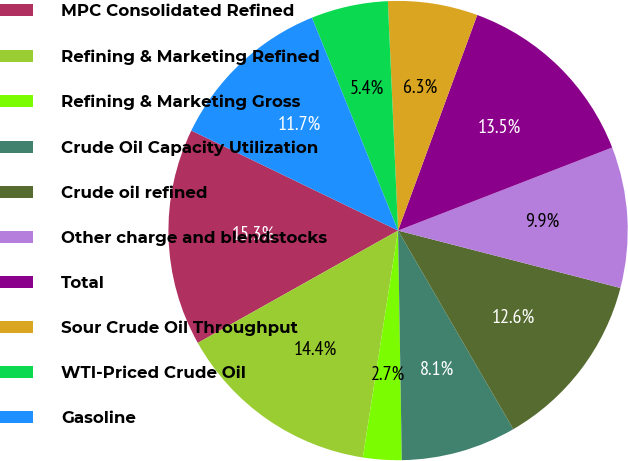Convert chart. <chart><loc_0><loc_0><loc_500><loc_500><pie_chart><fcel>MPC Consolidated Refined<fcel>Refining & Marketing Refined<fcel>Refining & Marketing Gross<fcel>Crude Oil Capacity Utilization<fcel>Crude oil refined<fcel>Other charge and blendstocks<fcel>Total<fcel>Sour Crude Oil Throughput<fcel>WTI-Priced Crude Oil<fcel>Gasoline<nl><fcel>15.31%<fcel>14.41%<fcel>2.71%<fcel>8.11%<fcel>12.61%<fcel>9.91%<fcel>13.51%<fcel>6.31%<fcel>5.41%<fcel>11.71%<nl></chart> 